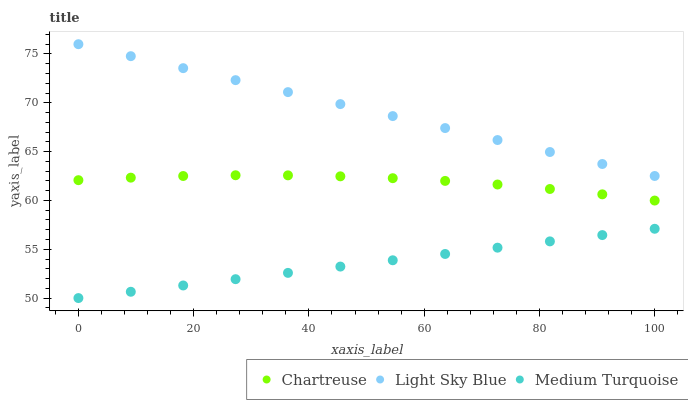Does Medium Turquoise have the minimum area under the curve?
Answer yes or no. Yes. Does Light Sky Blue have the maximum area under the curve?
Answer yes or no. Yes. Does Light Sky Blue have the minimum area under the curve?
Answer yes or no. No. Does Medium Turquoise have the maximum area under the curve?
Answer yes or no. No. Is Light Sky Blue the smoothest?
Answer yes or no. Yes. Is Chartreuse the roughest?
Answer yes or no. Yes. Is Medium Turquoise the smoothest?
Answer yes or no. No. Is Medium Turquoise the roughest?
Answer yes or no. No. Does Medium Turquoise have the lowest value?
Answer yes or no. Yes. Does Light Sky Blue have the lowest value?
Answer yes or no. No. Does Light Sky Blue have the highest value?
Answer yes or no. Yes. Does Medium Turquoise have the highest value?
Answer yes or no. No. Is Medium Turquoise less than Light Sky Blue?
Answer yes or no. Yes. Is Chartreuse greater than Medium Turquoise?
Answer yes or no. Yes. Does Medium Turquoise intersect Light Sky Blue?
Answer yes or no. No. 